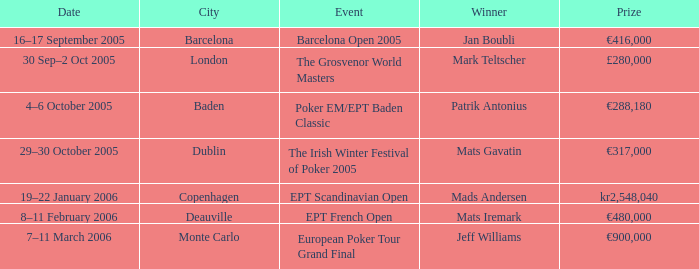Which happening had a €900,000 bounty? European Poker Tour Grand Final. 